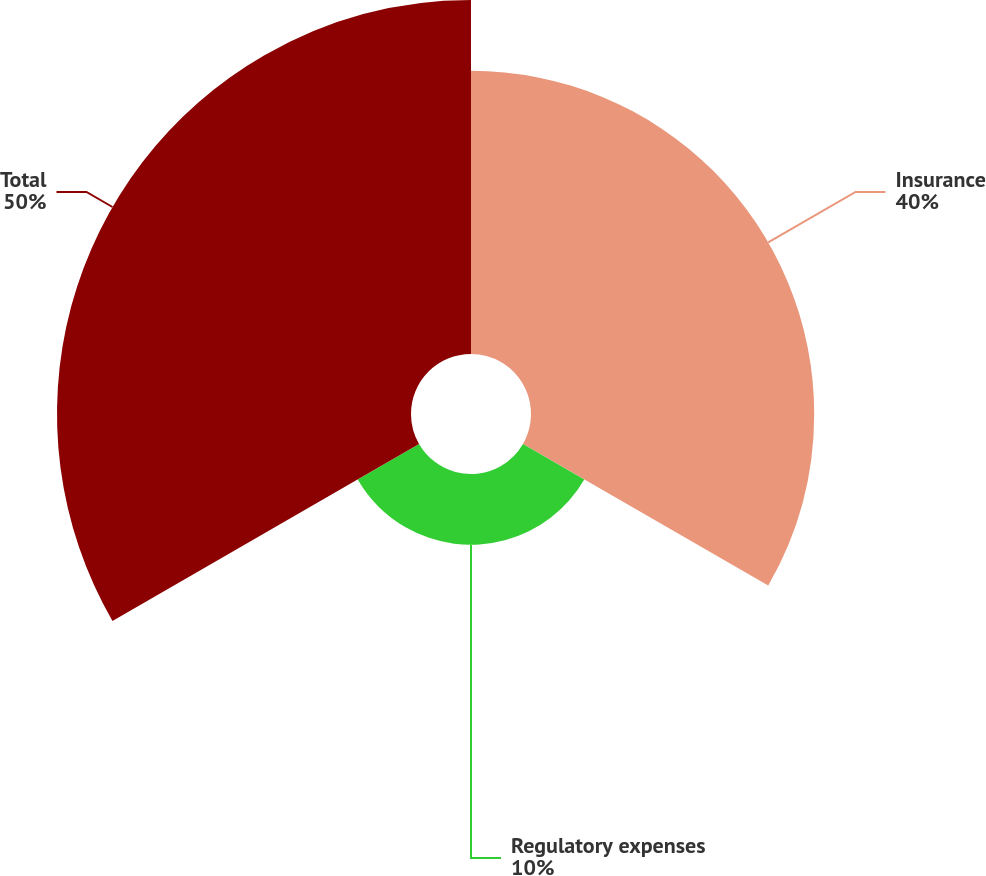<chart> <loc_0><loc_0><loc_500><loc_500><pie_chart><fcel>Insurance<fcel>Regulatory expenses<fcel>Total<nl><fcel>40.0%<fcel>10.0%<fcel>50.0%<nl></chart> 